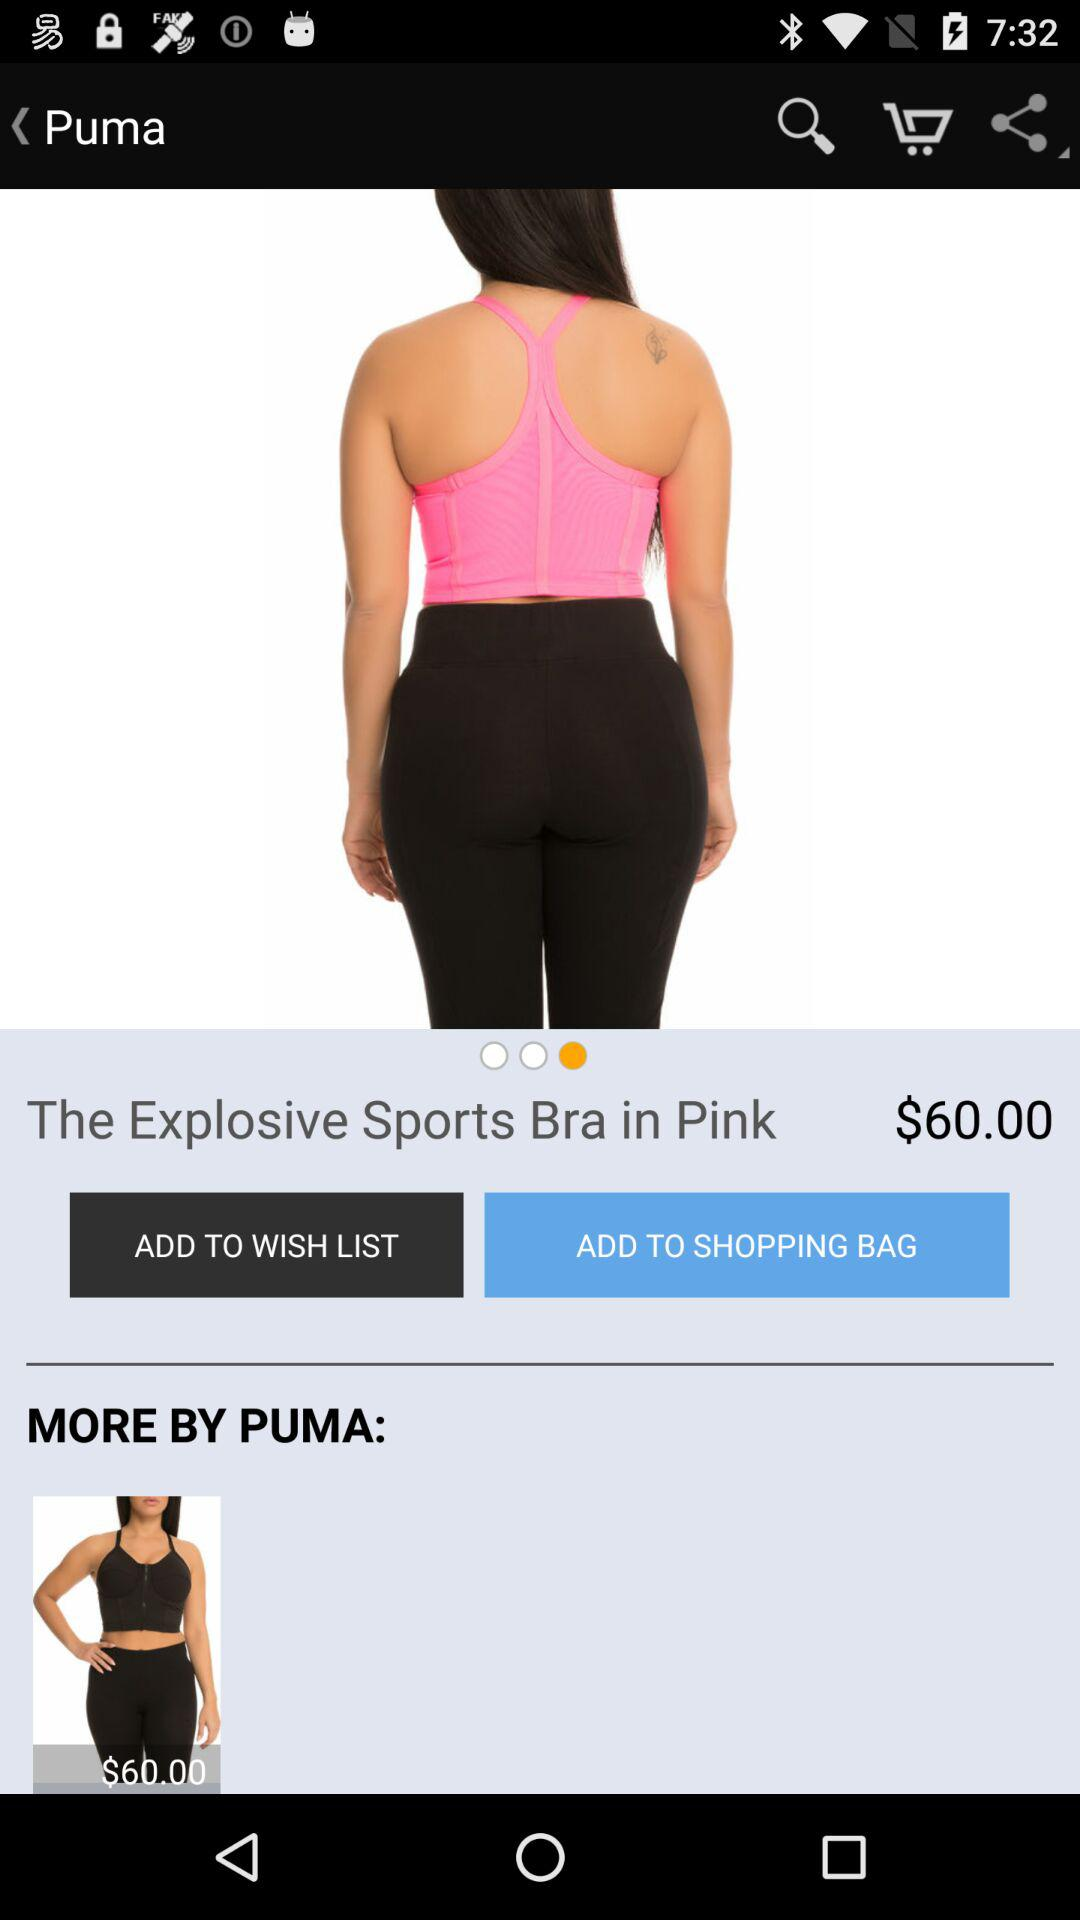What is the color of the product? The color of the product is pink. 